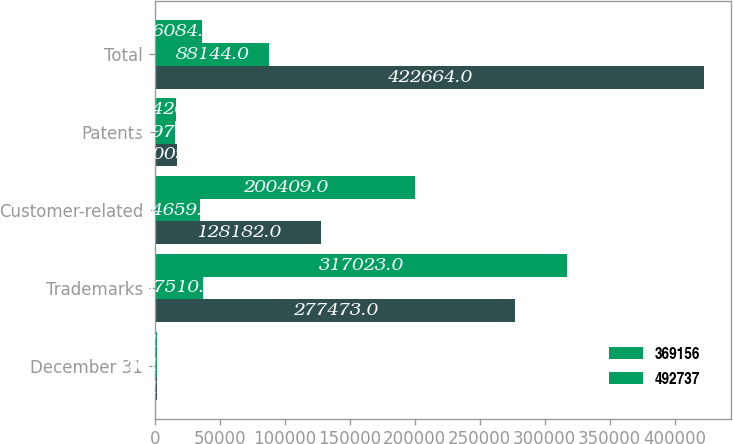Convert chart to OTSL. <chart><loc_0><loc_0><loc_500><loc_500><stacked_bar_chart><ecel><fcel>December 31<fcel>Trademarks<fcel>Customer-related<fcel>Patents<fcel>Total<nl><fcel>nan<fcel>2017<fcel>277473<fcel>128182<fcel>17009<fcel>422664<nl><fcel>369156<fcel>2017<fcel>37510<fcel>34659<fcel>15975<fcel>88144<nl><fcel>492737<fcel>2016<fcel>317023<fcel>200409<fcel>16426<fcel>36084.5<nl></chart> 